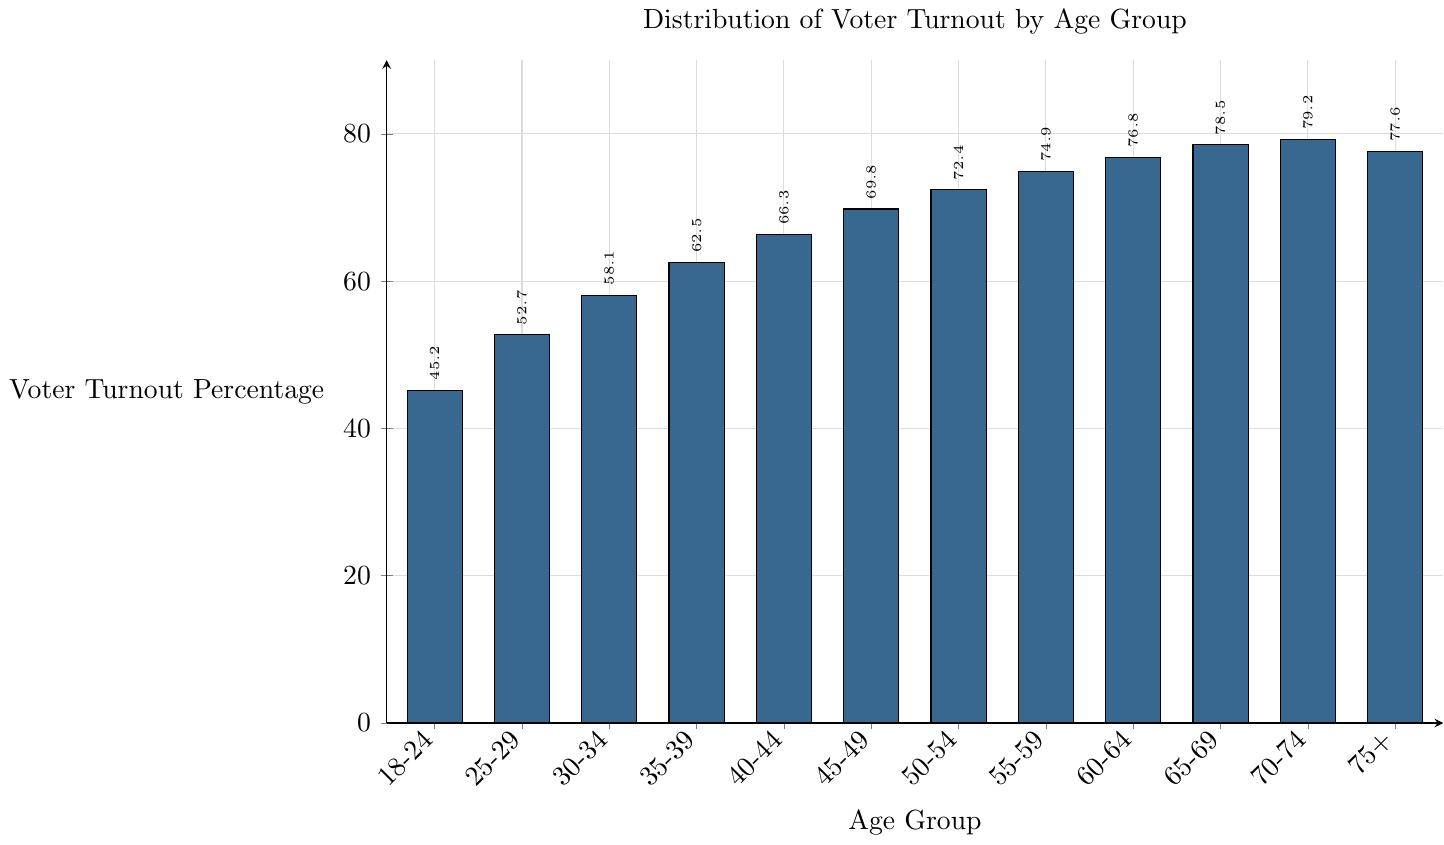What's the voter turnout percentage for the age group 18-24? Look at the bar corresponding to the age group 18-24 on the x-axis and read the value on the y-axis.
Answer: 45.2 Which age group has the highest voter turnout percentage? Identify the bar that reaches the highest point along the y-axis. This corresponds to the age group 70-74.
Answer: 70-74 Is the voter turnout percentage for the age group 75+ greater than the percentage for the age group 18-24? Compare the heights of the bars for the age groups 75+ and 18-24. The bar for 75+ reaches approximately 77.6, whereas the bar for 18-24 reaches 45.2.
Answer: Yes What is the difference in voter turnout percentage between the age group 40-44 and 25-29? Subtract the voter turnout percentage of the age group 25-29 from that of the age group 40-44 which is 66.3 - 52.7.
Answer: 13.6 What's the average voter turnout percentage for the age groups 50-54, 55-59, and 60-64? Add the voter turnout percentages for the age groups 50-54, 55-59, and 60-64 (72.4 + 74.9 + 76.8) and then divide by 3.
Answer: 74.7 Which age group shows a voter turnout percentage nearest to 75%? Examine the bars near the 75% mark on the y-axis and identify the closest one. The bar for the age group 60-64 reaches 76.8%.
Answer: 60-64 How does the voter turnout for the age group 35-39 compare to the age group 65-69? The bar for 35-39 is at 62.5%, and the bar for 65-69 is at 78.5%. Compare the heights visually to see that 65-69 is higher.
Answer: 65-69 is higher What's the median voter turnout percentage for all age groups? List all the percentages (45.2, 52.7, 58.1, 62.5, 66.3, 69.8, 72.4, 74.9, 76.8, 78.5, 79.2, 77.6), and find the middle value in the ordered set. There are 12 values, and the average of the 6th and 7th highest (69.8 and 72.4) gives the median (69.8+72.4)/2.
Answer: 71.1 Do the majority of age groups have a voter turnout percentage above 60%? Count the number of age groups whose voter turnout percentages are above 60% and compare it to the total number of age groups. 7 out of 12 (30-34 and older) have voter turnouts above 60%.
Answer: Yes 